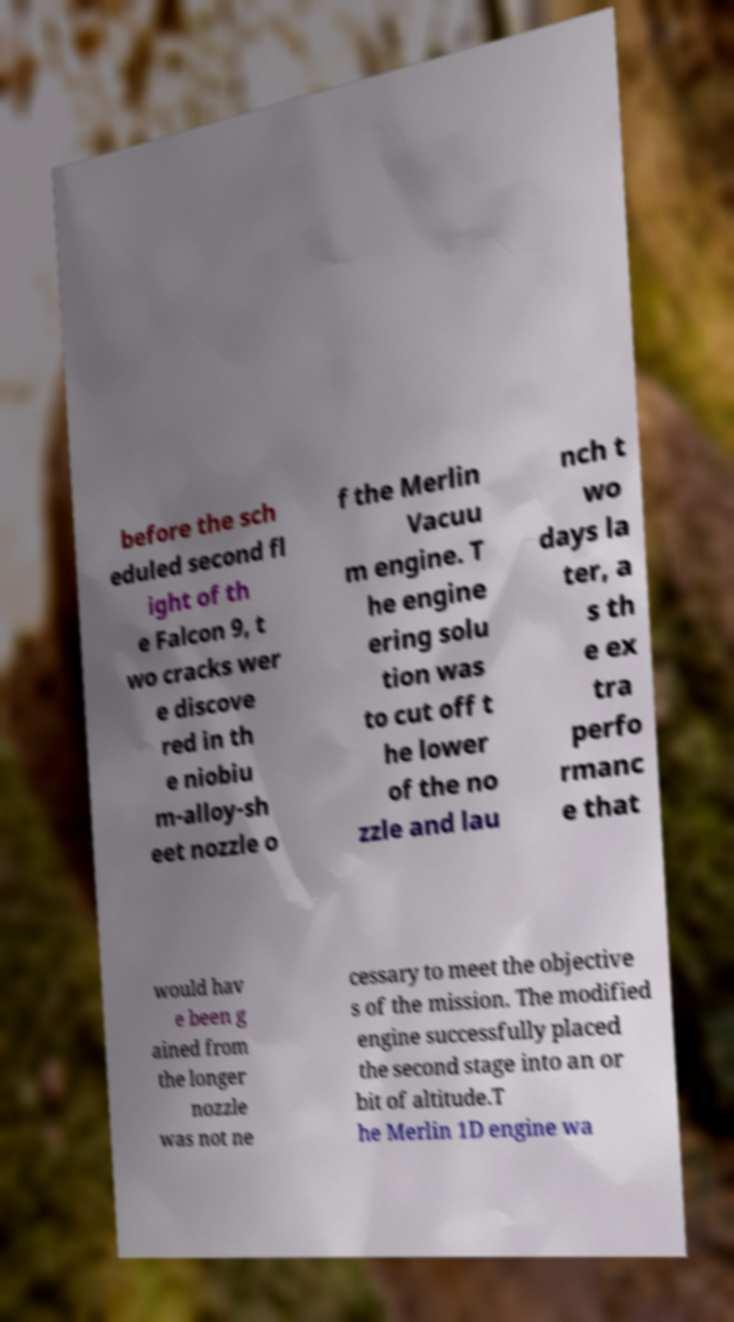Could you assist in decoding the text presented in this image and type it out clearly? before the sch eduled second fl ight of th e Falcon 9, t wo cracks wer e discove red in th e niobiu m-alloy-sh eet nozzle o f the Merlin Vacuu m engine. T he engine ering solu tion was to cut off t he lower of the no zzle and lau nch t wo days la ter, a s th e ex tra perfo rmanc e that would hav e been g ained from the longer nozzle was not ne cessary to meet the objective s of the mission. The modified engine successfully placed the second stage into an or bit of altitude.T he Merlin 1D engine wa 